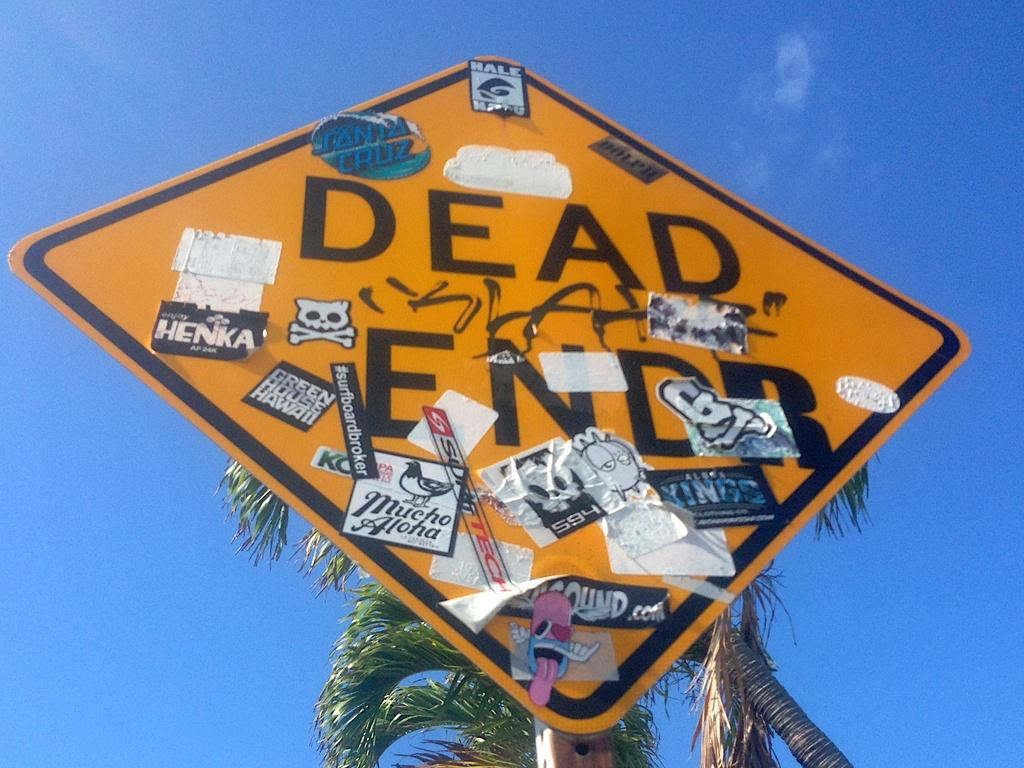<image>
Offer a succinct explanation of the picture presented. Green House Hawaii looks like one of the newest sticker placed on the sign. 